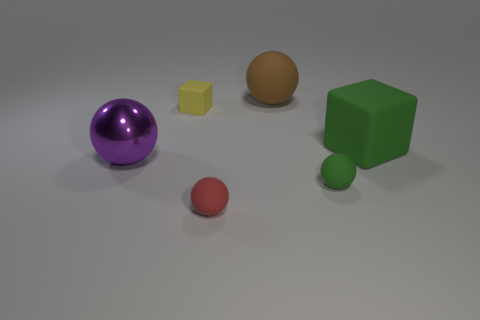Add 2 green cubes. How many objects exist? 8 Subtract all spheres. How many objects are left? 2 Add 5 small yellow blocks. How many small yellow blocks exist? 6 Subtract 0 gray cylinders. How many objects are left? 6 Subtract all big green rubber cubes. Subtract all red matte objects. How many objects are left? 4 Add 3 big purple objects. How many big purple objects are left? 4 